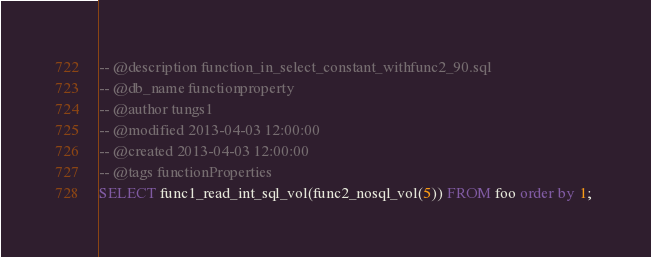Convert code to text. <code><loc_0><loc_0><loc_500><loc_500><_SQL_>-- @description function_in_select_constant_withfunc2_90.sql
-- @db_name functionproperty
-- @author tungs1
-- @modified 2013-04-03 12:00:00
-- @created 2013-04-03 12:00:00
-- @tags functionProperties 
SELECT func1_read_int_sql_vol(func2_nosql_vol(5)) FROM foo order by 1; 
</code> 